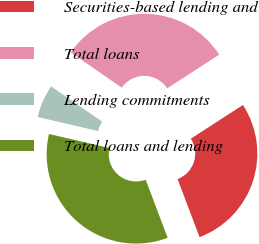Convert chart to OTSL. <chart><loc_0><loc_0><loc_500><loc_500><pie_chart><fcel>Securities-based lending and<fcel>Total loans<fcel>Lending commitments<fcel>Total loans and lending<nl><fcel>28.39%<fcel>31.23%<fcel>5.99%<fcel>34.38%<nl></chart> 